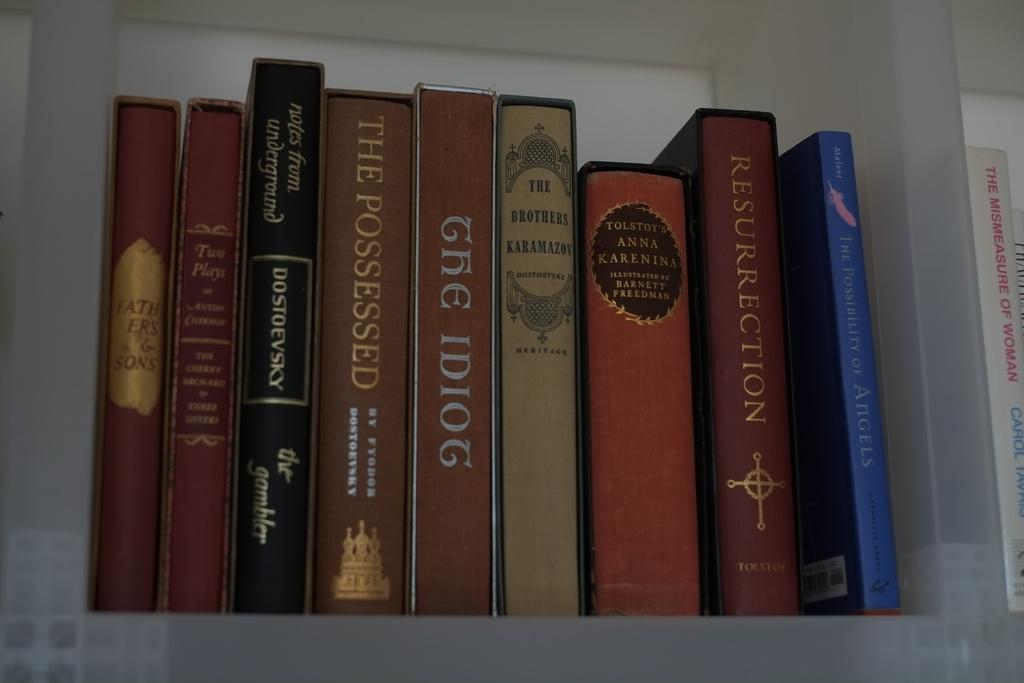<image>
Offer a succinct explanation of the picture presented. Books are lined up on a shelf, including The Possessed. 